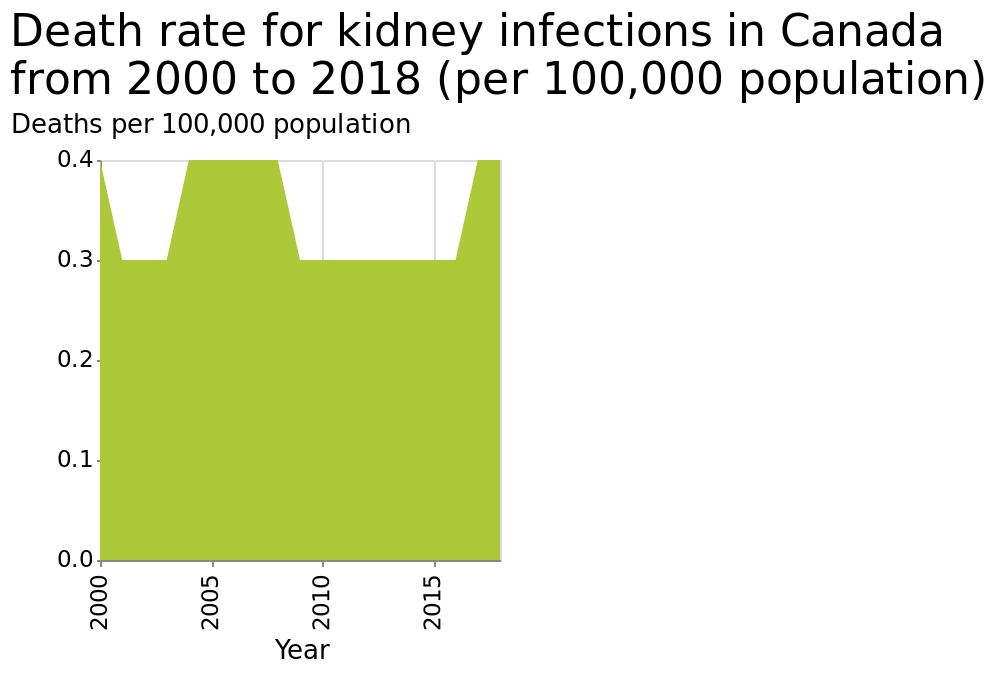<image>
What is shown on the x-axis of the graph?  The x-axis of the graph shows the years from 2000 to 2015. What were the years with a death rate of 0.4?  The years with a death rate of 0.4 were 2000, 2004-2008, and 2017-2018. Describe the following image in detail Death rate for kidney infections in Canada from 2000 to 2018 (per 100,000 population) is a area graph. On the y-axis, Deaths per 100,000 population is shown. Along the x-axis, Year is shown as a linear scale with a minimum of 2000 and a maximum of 2015. What is the graph representing?  The graph represents the death rate for kidney infections in Canada from 2000 to 2018. 